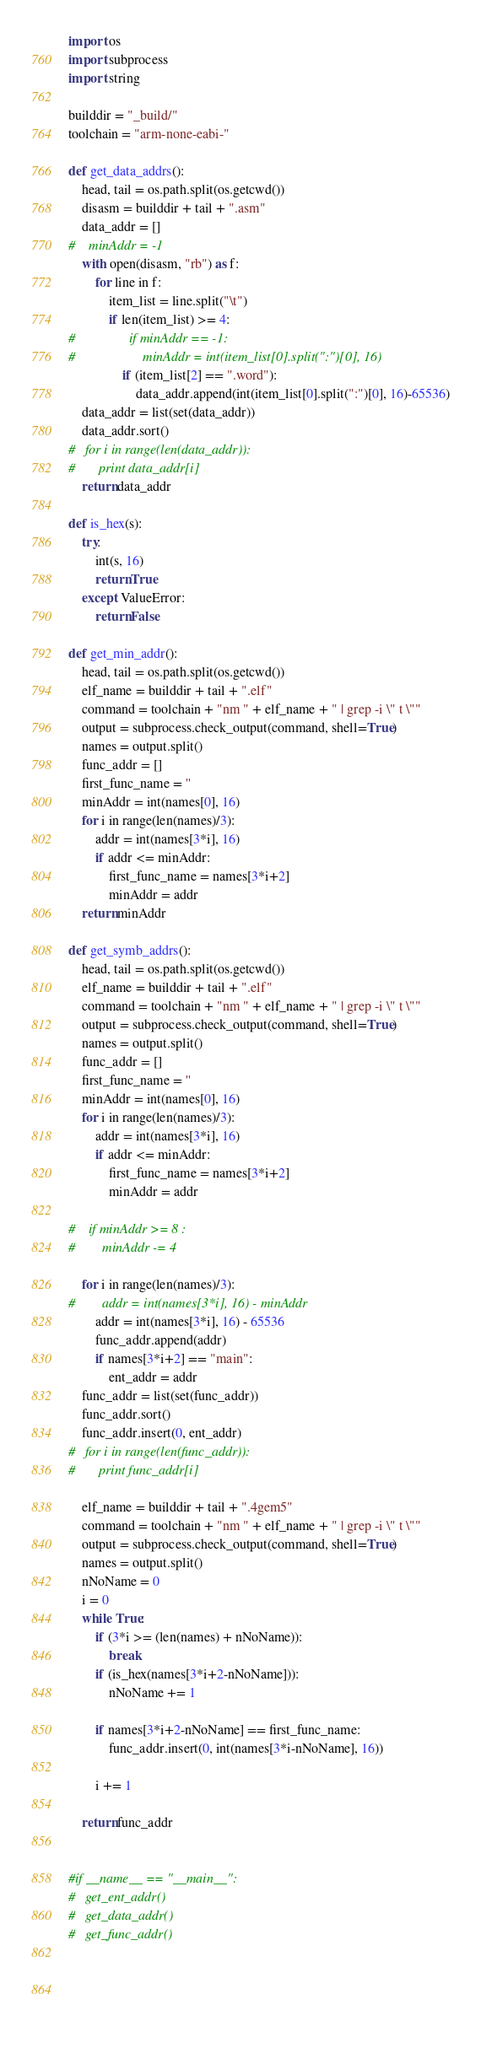<code> <loc_0><loc_0><loc_500><loc_500><_Python_>import os
import subprocess
import string

builddir = "_build/"
toolchain = "arm-none-eabi-"

def get_data_addrs():
    head, tail = os.path.split(os.getcwd())
    disasm = builddir + tail + ".asm"
    data_addr = []
#    minAddr = -1
    with open(disasm, "rb") as f:
        for line in f:
            item_list = line.split("\t")
            if len(item_list) >= 4:
#                if minAddr == -1:
#                    minAddr = int(item_list[0].split(":")[0], 16)
                if (item_list[2] == ".word"):
                    data_addr.append(int(item_list[0].split(":")[0], 16)-65536)
    data_addr = list(set(data_addr))
    data_addr.sort()
#	for i in range(len(data_addr)):
#		print data_addr[i]
    return data_addr

def is_hex(s):
    try:
        int(s, 16)
        return True
    except ValueError:
        return False

def get_min_addr():
    head, tail = os.path.split(os.getcwd())
    elf_name = builddir + tail + ".elf"
    command = toolchain + "nm " + elf_name + " | grep -i \" t \""
    output = subprocess.check_output(command, shell=True)
    names = output.split()
    func_addr = []
    first_func_name = ''
    minAddr = int(names[0], 16)
    for i in range(len(names)/3):
        addr = int(names[3*i], 16)
        if addr <= minAddr:
            first_func_name = names[3*i+2]
            minAddr = addr
    return minAddr
 
def get_symb_addrs():
    head, tail = os.path.split(os.getcwd())
    elf_name = builddir + tail + ".elf"
    command = toolchain + "nm " + elf_name + " | grep -i \" t \""
    output = subprocess.check_output(command, shell=True)
    names = output.split()
    func_addr = []
    first_func_name = ''
    minAddr = int(names[0], 16)
    for i in range(len(names)/3):
        addr = int(names[3*i], 16)
        if addr <= minAddr:
            first_func_name = names[3*i+2]
            minAddr = addr
 
#    if minAddr >= 8 :
#        minAddr -= 4

    for i in range(len(names)/3):
#        addr = int(names[3*i], 16) - minAddr
        addr = int(names[3*i], 16) - 65536
        func_addr.append(addr)  
        if names[3*i+2] == "main":
            ent_addr = addr
    func_addr = list(set(func_addr))	
    func_addr.sort()
    func_addr.insert(0, ent_addr)
#	for i in range(len(func_addr)):
#		print func_addr[i]

    elf_name = builddir + tail + ".4gem5"
    command = toolchain + "nm " + elf_name + " | grep -i \" t \""
    output = subprocess.check_output(command, shell=True)
    names = output.split()
    nNoName = 0
    i = 0
    while True:
        if (3*i >= (len(names) + nNoName)):
            break
        if (is_hex(names[3*i+2-nNoName])):
            nNoName += 1

        if names[3*i+2-nNoName] == first_func_name:
            func_addr.insert(0, int(names[3*i-nNoName], 16))

        i += 1

    return func_addr


#if __name__ == "__main__":
#	get_ent_addr()
#	get_data_addr()
#	get_func_addr()



    






</code> 